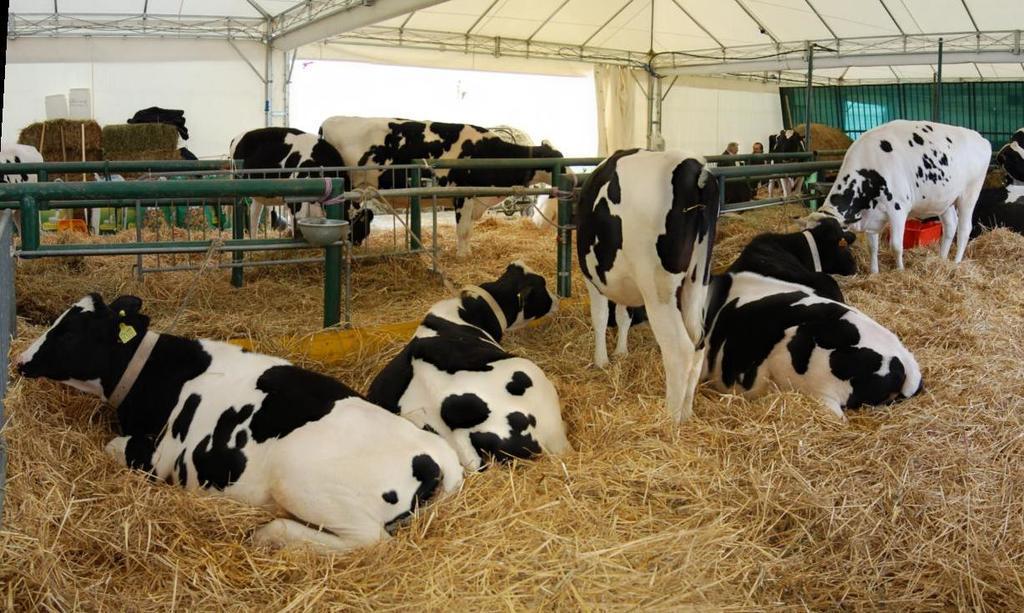How would you summarize this image in a sentence or two? In this image, we can see animals and some are lying. In the background, there are railings and we can see some people and there are rods and we can see a heap of grass and a board. At the bottom, there is grass. 